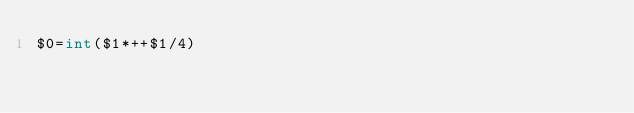<code> <loc_0><loc_0><loc_500><loc_500><_Awk_>$0=int($1*++$1/4)</code> 